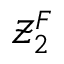Convert formula to latex. <formula><loc_0><loc_0><loc_500><loc_500>\mathcal { Z } _ { 2 } ^ { F }</formula> 